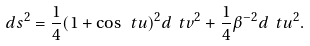Convert formula to latex. <formula><loc_0><loc_0><loc_500><loc_500>d s ^ { 2 } = \frac { 1 } { 4 } ( 1 + \cos \ t { u } ) ^ { 2 } d \ t { v } ^ { 2 } + \frac { 1 } { 4 } \beta ^ { - 2 } d \ t { u } ^ { 2 } .</formula> 